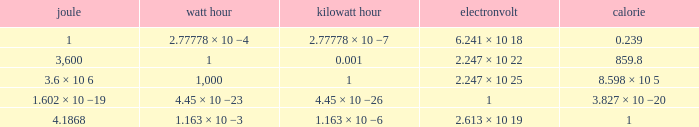How many electronvolts is 3,600 joules? 2.247 × 10 22. 